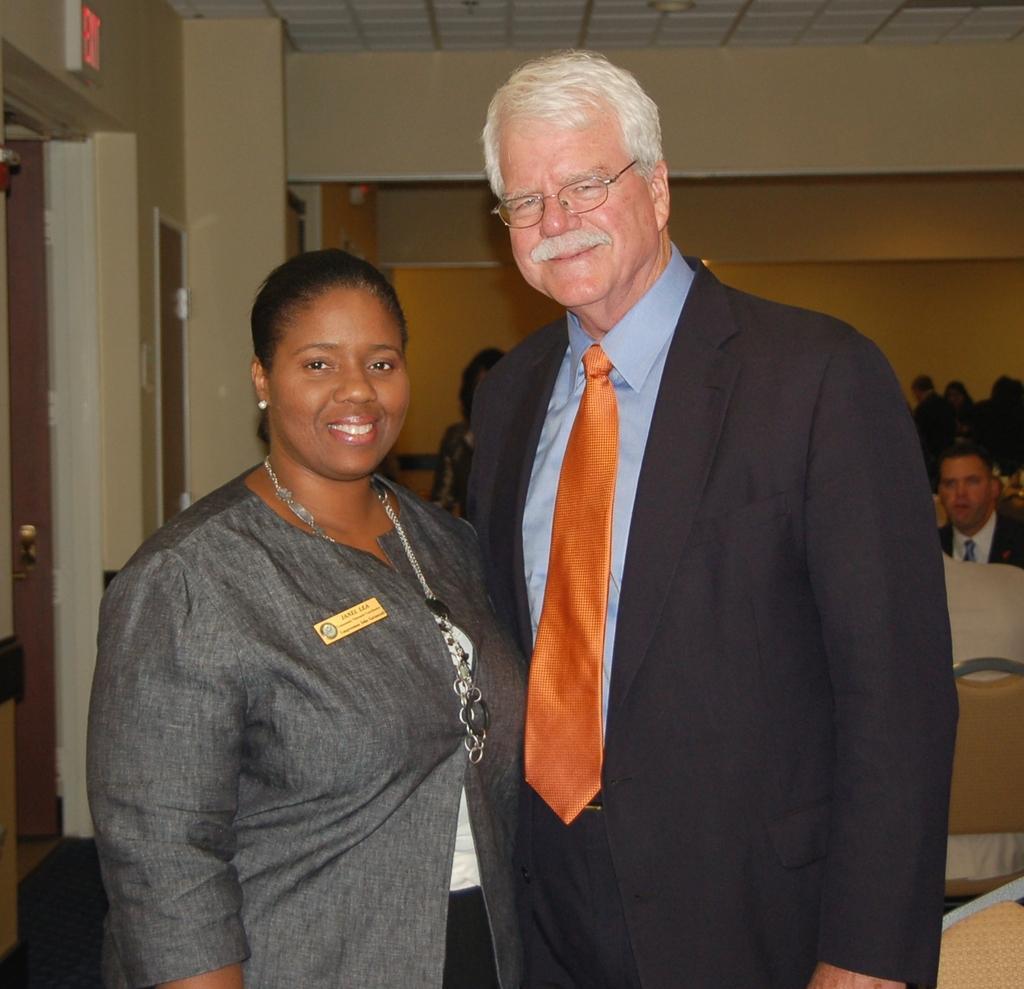Could you give a brief overview of what you see in this image? In the image we can see a man and a woman standing. They are wearing clothes and they are smiling. This is a batch, neck chain, earring and spectacles. Behind them there are other people wearing clothes. These are the chairs, door and a floor. 